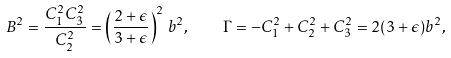Convert formula to latex. <formula><loc_0><loc_0><loc_500><loc_500>B ^ { 2 } = \frac { C _ { 1 } ^ { 2 } C _ { 3 } ^ { 2 } } { C _ { 2 } ^ { 2 } } = \left ( \frac { 2 + \epsilon } { 3 + \epsilon } \right ) ^ { 2 } \, b ^ { 2 } , \quad \Gamma = - C _ { 1 } ^ { 2 } + C _ { 2 } ^ { 2 } + C _ { 3 } ^ { 2 } = 2 ( 3 + \epsilon ) b ^ { 2 } ,</formula> 